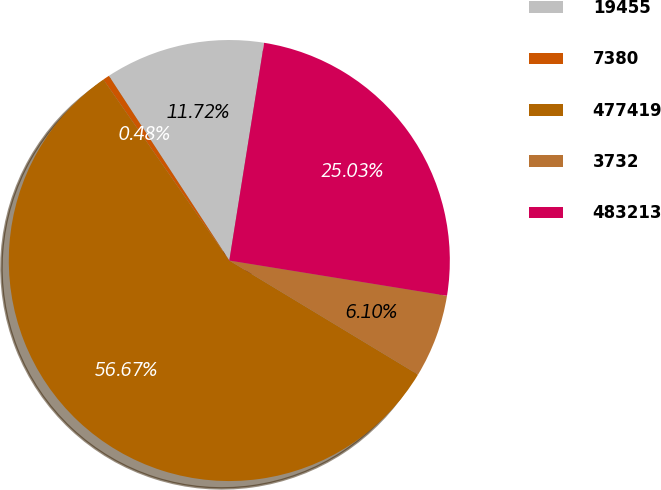Convert chart. <chart><loc_0><loc_0><loc_500><loc_500><pie_chart><fcel>19455<fcel>7380<fcel>477419<fcel>3732<fcel>483213<nl><fcel>11.72%<fcel>0.48%<fcel>56.67%<fcel>6.1%<fcel>25.03%<nl></chart> 